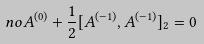Convert formula to latex. <formula><loc_0><loc_0><loc_500><loc_500>\ n o A ^ { ( 0 ) } + { \frac { 1 } { 2 } } [ A ^ { ( - 1 ) } , A ^ { ( - 1 ) } ] _ { 2 } = 0</formula> 